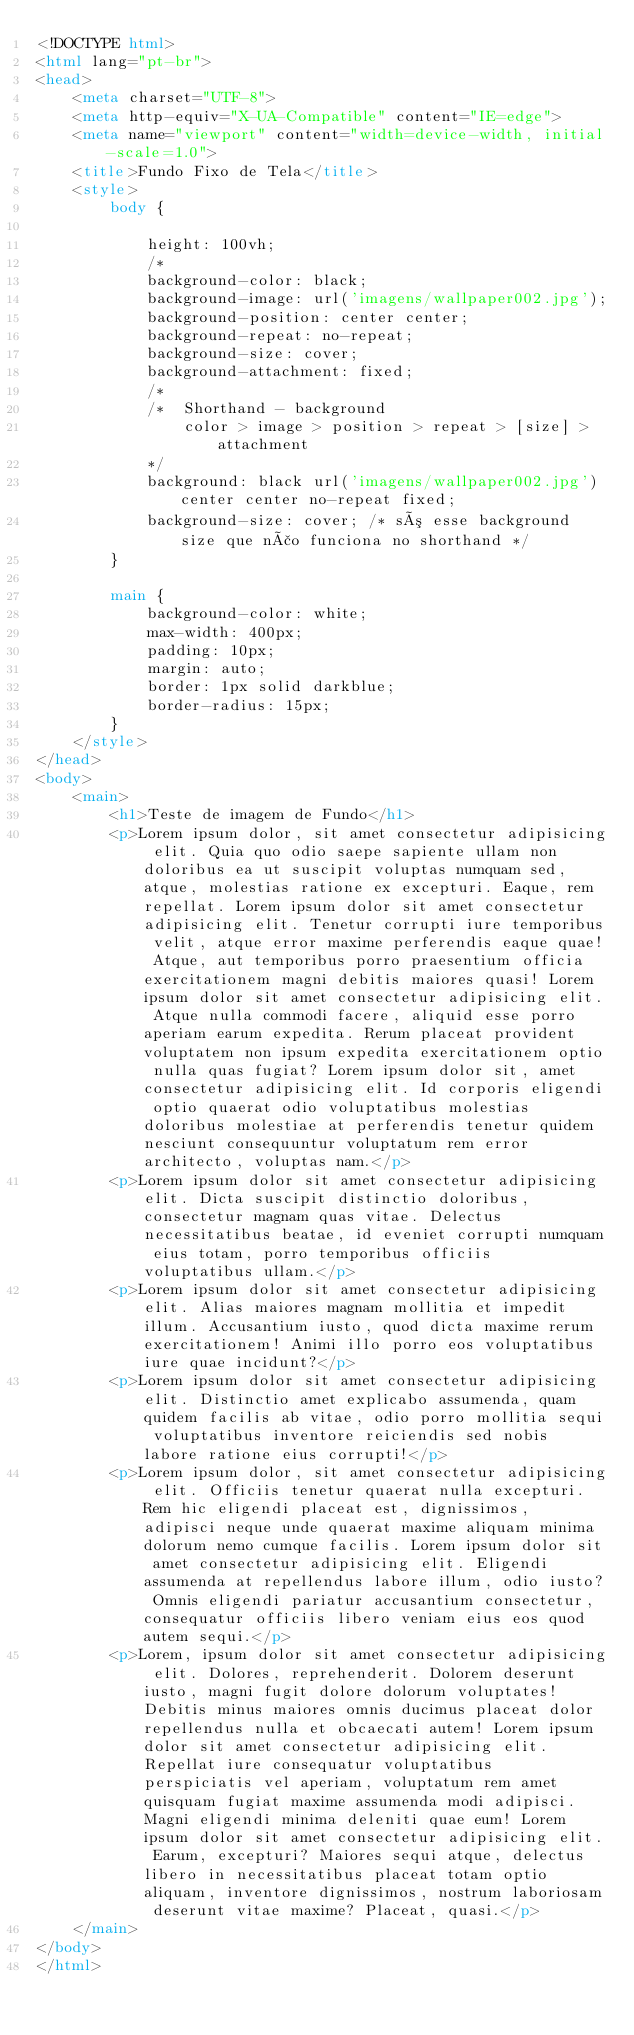<code> <loc_0><loc_0><loc_500><loc_500><_HTML_><!DOCTYPE html>
<html lang="pt-br">
<head>
    <meta charset="UTF-8">
    <meta http-equiv="X-UA-Compatible" content="IE=edge">
    <meta name="viewport" content="width=device-width, initial-scale=1.0">
    <title>Fundo Fixo de Tela</title>
    <style>
        body {
            
            height: 100vh;
            /*
            background-color: black;
            background-image: url('imagens/wallpaper002.jpg');
            background-position: center center;
            background-repeat: no-repeat;
            background-size: cover;
            background-attachment: fixed; 
            /*
            /*  Shorthand - background 
                color > image > position > repeat > [size] > attachment 
            */
            background: black url('imagens/wallpaper002.jpg') center center no-repeat fixed;
            background-size: cover; /* só esse background size que não funciona no shorthand */
        }

        main {
            background-color: white;
            max-width: 400px;
            padding: 10px;
            margin: auto;
            border: 1px solid darkblue;
            border-radius: 15px;
        }
    </style>
</head>
<body>
    <main>
        <h1>Teste de imagem de Fundo</h1>
        <p>Lorem ipsum dolor, sit amet consectetur adipisicing elit. Quia quo odio saepe sapiente ullam non doloribus ea ut suscipit voluptas numquam sed, atque, molestias ratione ex excepturi. Eaque, rem repellat. Lorem ipsum dolor sit amet consectetur adipisicing elit. Tenetur corrupti iure temporibus velit, atque error maxime perferendis eaque quae! Atque, aut temporibus porro praesentium officia exercitationem magni debitis maiores quasi! Lorem ipsum dolor sit amet consectetur adipisicing elit. Atque nulla commodi facere, aliquid esse porro aperiam earum expedita. Rerum placeat provident voluptatem non ipsum expedita exercitationem optio nulla quas fugiat? Lorem ipsum dolor sit, amet consectetur adipisicing elit. Id corporis eligendi optio quaerat odio voluptatibus molestias doloribus molestiae at perferendis tenetur quidem nesciunt consequuntur voluptatum rem error architecto, voluptas nam.</p>
        <p>Lorem ipsum dolor sit amet consectetur adipisicing elit. Dicta suscipit distinctio doloribus, consectetur magnam quas vitae. Delectus necessitatibus beatae, id eveniet corrupti numquam eius totam, porro temporibus officiis voluptatibus ullam.</p>
        <p>Lorem ipsum dolor sit amet consectetur adipisicing elit. Alias maiores magnam mollitia et impedit illum. Accusantium iusto, quod dicta maxime rerum exercitationem! Animi illo porro eos voluptatibus iure quae incidunt?</p>
        <p>Lorem ipsum dolor sit amet consectetur adipisicing elit. Distinctio amet explicabo assumenda, quam quidem facilis ab vitae, odio porro mollitia sequi voluptatibus inventore reiciendis sed nobis labore ratione eius corrupti!</p>
        <p>Lorem ipsum dolor, sit amet consectetur adipisicing elit. Officiis tenetur quaerat nulla excepturi. Rem hic eligendi placeat est, dignissimos, adipisci neque unde quaerat maxime aliquam minima dolorum nemo cumque facilis. Lorem ipsum dolor sit amet consectetur adipisicing elit. Eligendi assumenda at repellendus labore illum, odio iusto? Omnis eligendi pariatur accusantium consectetur, consequatur officiis libero veniam eius eos quod autem sequi.</p>
        <p>Lorem, ipsum dolor sit amet consectetur adipisicing elit. Dolores, reprehenderit. Dolorem deserunt iusto, magni fugit dolore dolorum voluptates! Debitis minus maiores omnis ducimus placeat dolor repellendus nulla et obcaecati autem! Lorem ipsum dolor sit amet consectetur adipisicing elit. Repellat iure consequatur voluptatibus perspiciatis vel aperiam, voluptatum rem amet quisquam fugiat maxime assumenda modi adipisci. Magni eligendi minima deleniti quae eum! Lorem ipsum dolor sit amet consectetur adipisicing elit. Earum, excepturi? Maiores sequi atque, delectus libero in necessitatibus placeat totam optio aliquam, inventore dignissimos, nostrum laboriosam deserunt vitae maxime? Placeat, quasi.</p>
    </main>
</body>
</html></code> 